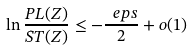<formula> <loc_0><loc_0><loc_500><loc_500>\ln \frac { P L ( Z ) } { S T ( Z ) } \leq - \frac { \ e p s } { 2 } + o ( 1 )</formula> 